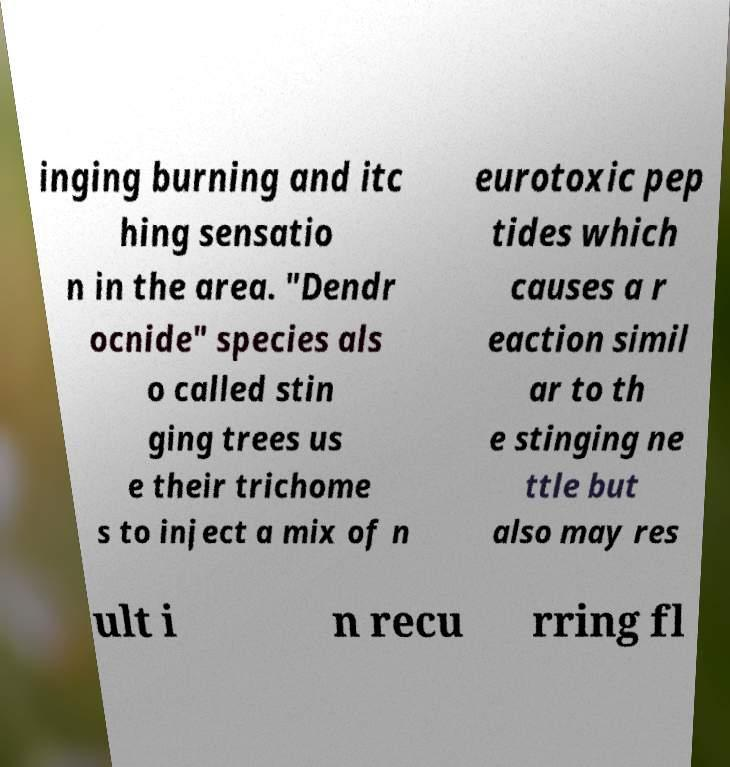Please identify and transcribe the text found in this image. inging burning and itc hing sensatio n in the area. "Dendr ocnide" species als o called stin ging trees us e their trichome s to inject a mix of n eurotoxic pep tides which causes a r eaction simil ar to th e stinging ne ttle but also may res ult i n recu rring fl 